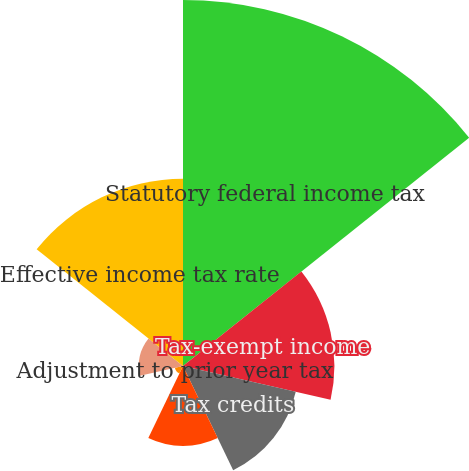Convert chart. <chart><loc_0><loc_0><loc_500><loc_500><pie_chart><fcel>Statutory federal income tax<fcel>Tax-exempt income<fcel>Tax credits<fcel>Dividends received deduction<fcel>Adjustment to prior year tax<fcel>Other<fcel>Effective income tax rate<nl><fcel>38.42%<fcel>15.89%<fcel>12.14%<fcel>8.39%<fcel>0.88%<fcel>4.63%<fcel>19.65%<nl></chart> 